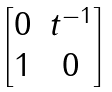<formula> <loc_0><loc_0><loc_500><loc_500>\begin{bmatrix} 0 & t ^ { - 1 } \\ 1 & 0 \end{bmatrix}</formula> 